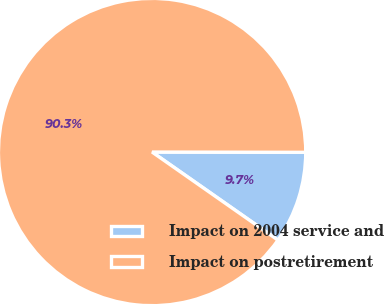Convert chart to OTSL. <chart><loc_0><loc_0><loc_500><loc_500><pie_chart><fcel>Impact on 2004 service and<fcel>Impact on postretirement<nl><fcel>9.69%<fcel>90.31%<nl></chart> 